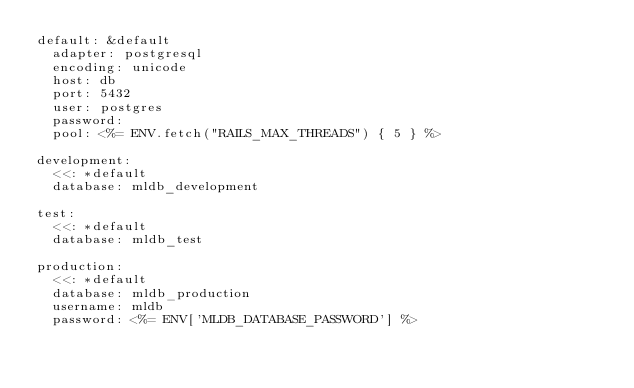Convert code to text. <code><loc_0><loc_0><loc_500><loc_500><_YAML_>default: &default
  adapter: postgresql
  encoding: unicode
  host: db
  port: 5432
  user: postgres
  password:
  pool: <%= ENV.fetch("RAILS_MAX_THREADS") { 5 } %>

development:
  <<: *default
  database: mldb_development

test:
  <<: *default
  database: mldb_test

production:
  <<: *default
  database: mldb_production
  username: mldb
  password: <%= ENV['MLDB_DATABASE_PASSWORD'] %>
</code> 